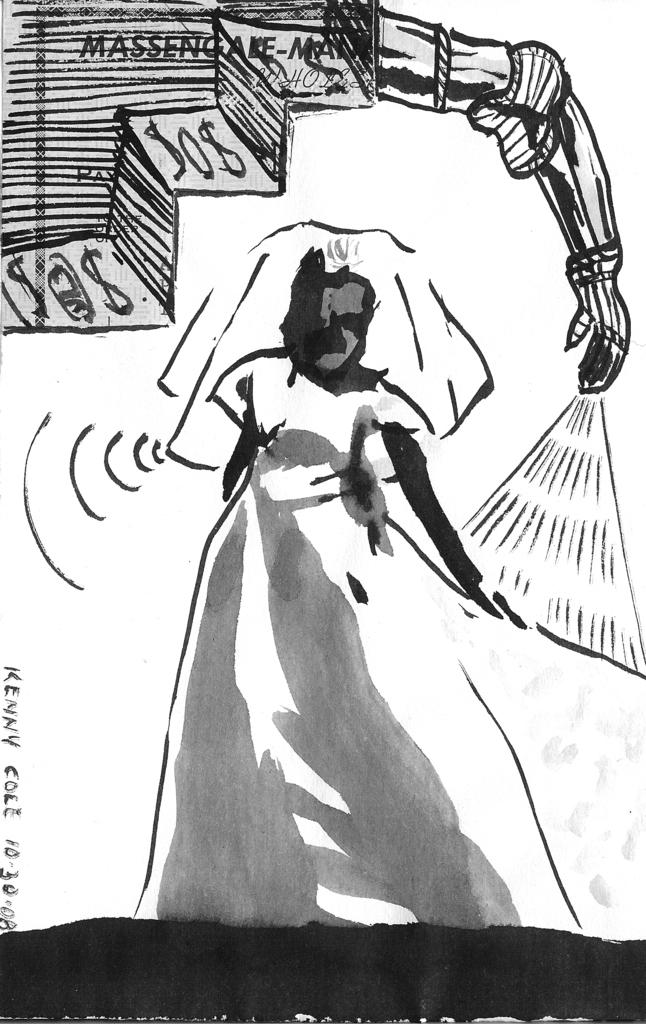What is the main subject of the image? There is a sketch in the image. Can you hear the kitten whistling on the island in the image? There is no kitten, whistling, or island present in the image; it only contains a sketch. 